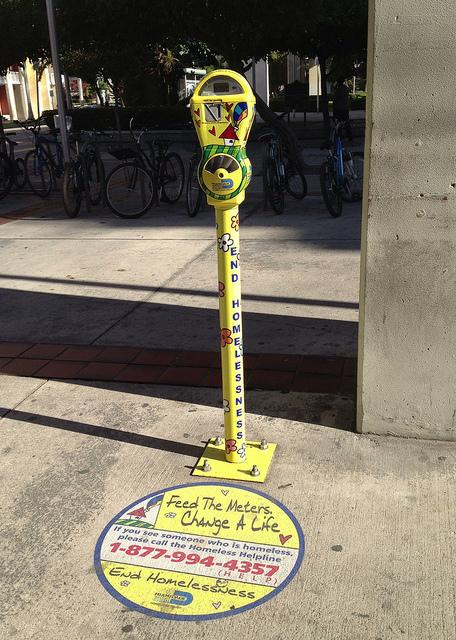What are they hoping to collect?

Choices:
A) coins
B) points
C) ideas
D) signatures coins 